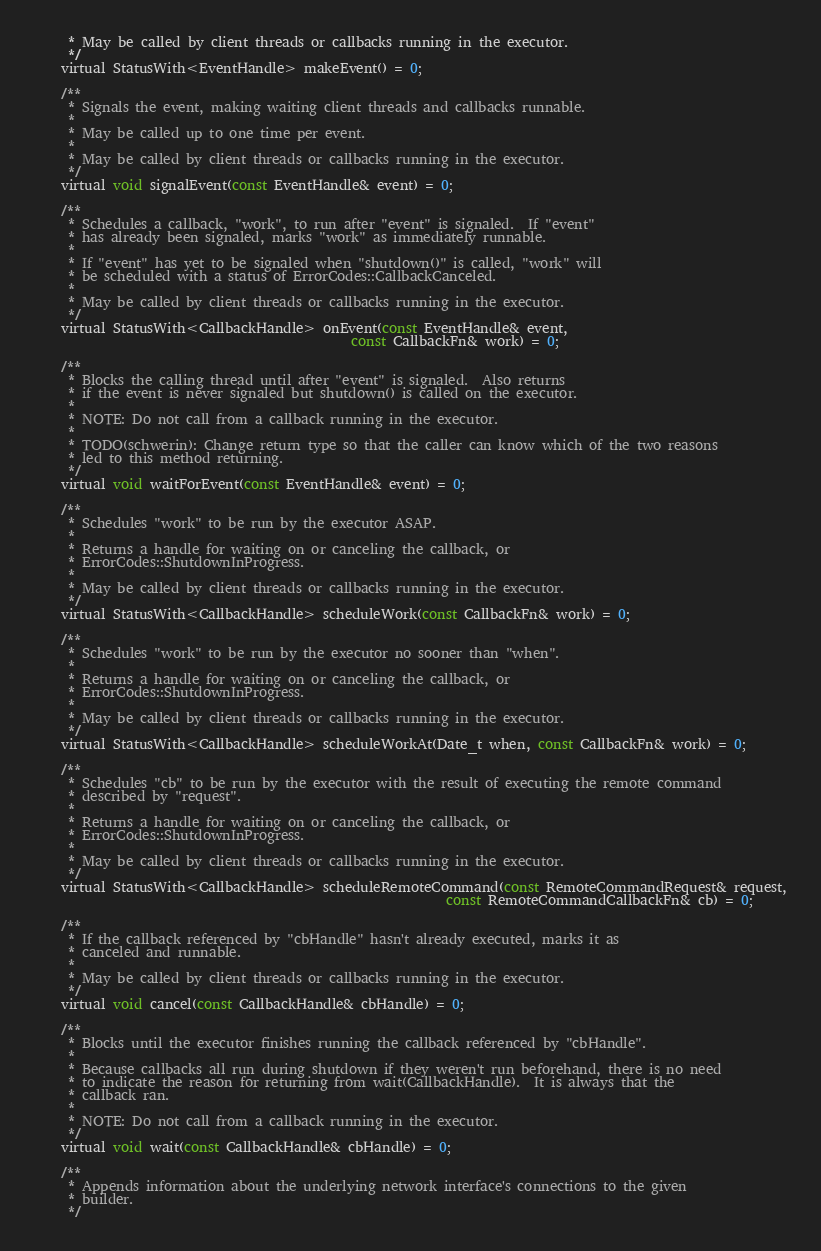Convert code to text. <code><loc_0><loc_0><loc_500><loc_500><_C_>     * May be called by client threads or callbacks running in the executor.
     */
    virtual StatusWith<EventHandle> makeEvent() = 0;

    /**
     * Signals the event, making waiting client threads and callbacks runnable.
     *
     * May be called up to one time per event.
     *
     * May be called by client threads or callbacks running in the executor.
     */
    virtual void signalEvent(const EventHandle& event) = 0;

    /**
     * Schedules a callback, "work", to run after "event" is signaled.  If "event"
     * has already been signaled, marks "work" as immediately runnable.
     *
     * If "event" has yet to be signaled when "shutdown()" is called, "work" will
     * be scheduled with a status of ErrorCodes::CallbackCanceled.
     *
     * May be called by client threads or callbacks running in the executor.
     */
    virtual StatusWith<CallbackHandle> onEvent(const EventHandle& event,
                                               const CallbackFn& work) = 0;

    /**
     * Blocks the calling thread until after "event" is signaled.  Also returns
     * if the event is never signaled but shutdown() is called on the executor.
     *
     * NOTE: Do not call from a callback running in the executor.
     *
     * TODO(schwerin): Change return type so that the caller can know which of the two reasons
     * led to this method returning.
     */
    virtual void waitForEvent(const EventHandle& event) = 0;

    /**
     * Schedules "work" to be run by the executor ASAP.
     *
     * Returns a handle for waiting on or canceling the callback, or
     * ErrorCodes::ShutdownInProgress.
     *
     * May be called by client threads or callbacks running in the executor.
     */
    virtual StatusWith<CallbackHandle> scheduleWork(const CallbackFn& work) = 0;

    /**
     * Schedules "work" to be run by the executor no sooner than "when".
     *
     * Returns a handle for waiting on or canceling the callback, or
     * ErrorCodes::ShutdownInProgress.
     *
     * May be called by client threads or callbacks running in the executor.
     */
    virtual StatusWith<CallbackHandle> scheduleWorkAt(Date_t when, const CallbackFn& work) = 0;

    /**
     * Schedules "cb" to be run by the executor with the result of executing the remote command
     * described by "request".
     *
     * Returns a handle for waiting on or canceling the callback, or
     * ErrorCodes::ShutdownInProgress.
     *
     * May be called by client threads or callbacks running in the executor.
     */
    virtual StatusWith<CallbackHandle> scheduleRemoteCommand(const RemoteCommandRequest& request,
                                                             const RemoteCommandCallbackFn& cb) = 0;

    /**
     * If the callback referenced by "cbHandle" hasn't already executed, marks it as
     * canceled and runnable.
     *
     * May be called by client threads or callbacks running in the executor.
     */
    virtual void cancel(const CallbackHandle& cbHandle) = 0;

    /**
     * Blocks until the executor finishes running the callback referenced by "cbHandle".
     *
     * Because callbacks all run during shutdown if they weren't run beforehand, there is no need
     * to indicate the reason for returning from wait(CallbackHandle).  It is always that the
     * callback ran.
     *
     * NOTE: Do not call from a callback running in the executor.
     */
    virtual void wait(const CallbackHandle& cbHandle) = 0;

    /**
     * Appends information about the underlying network interface's connections to the given
     * builder.
     */</code> 